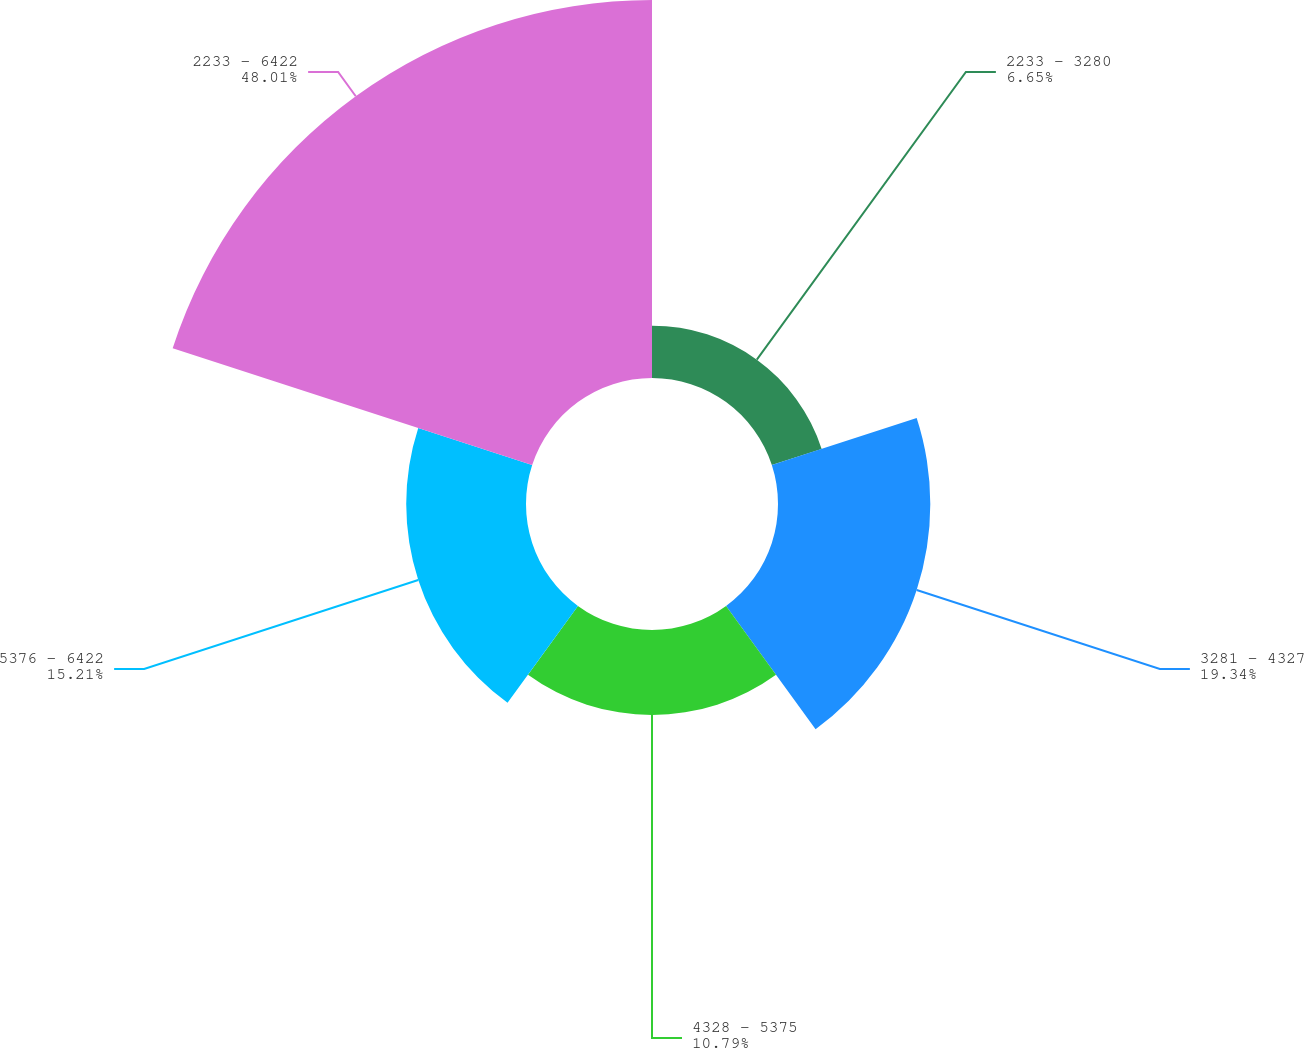Convert chart to OTSL. <chart><loc_0><loc_0><loc_500><loc_500><pie_chart><fcel>2233 - 3280<fcel>3281 - 4327<fcel>4328 - 5375<fcel>5376 - 6422<fcel>2233 - 6422<nl><fcel>6.65%<fcel>19.34%<fcel>10.79%<fcel>15.21%<fcel>48.0%<nl></chart> 